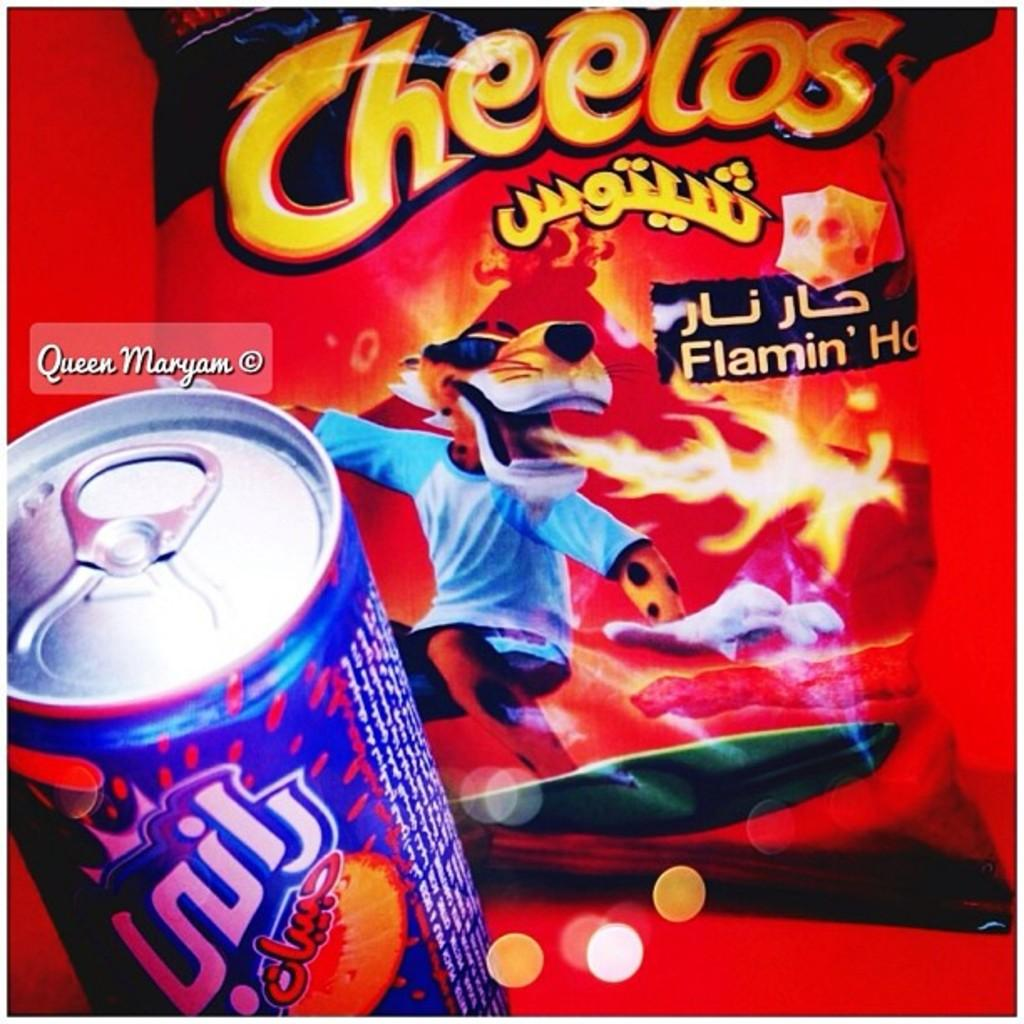<image>
Render a clear and concise summary of the photo. A soda and a bag of Flaming Hot Cheetos 